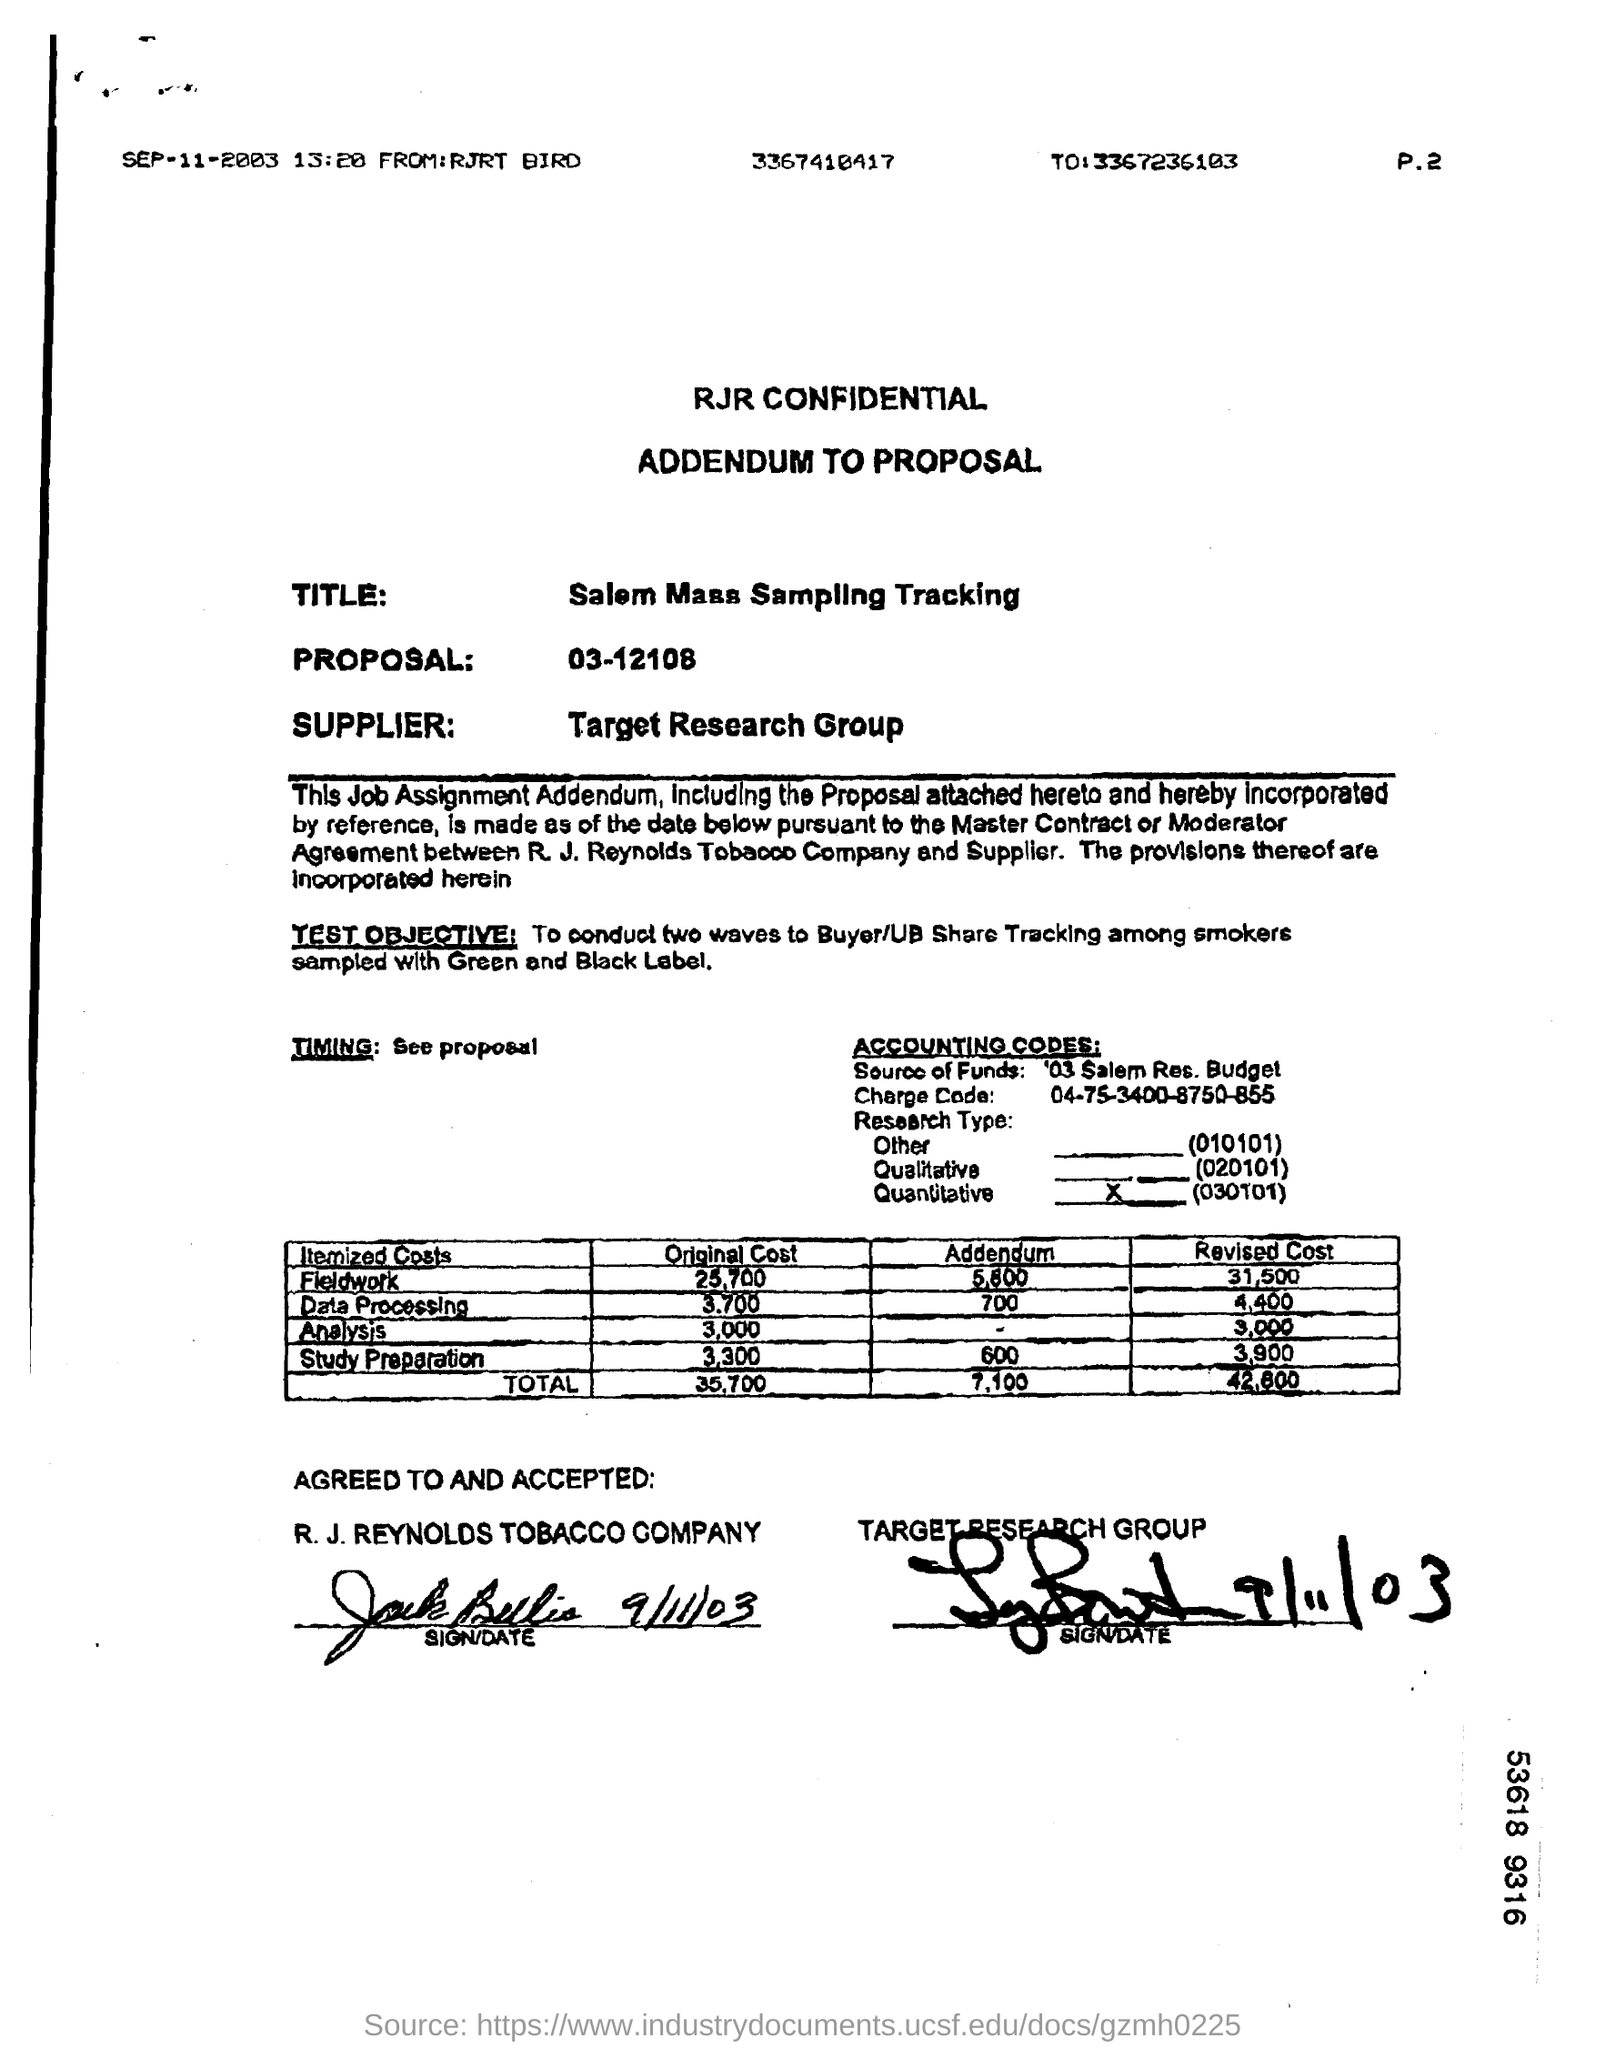What is the Title?
Your response must be concise. Salem Mass Sampling Tracking. Who is the supplier?
Your answer should be very brief. Target Research Group. What is the "Addendum" for "Field Work"?
Provide a short and direct response. 5,800. What is the "Total" for "Revised Cost"?
Give a very brief answer. 42,800. 